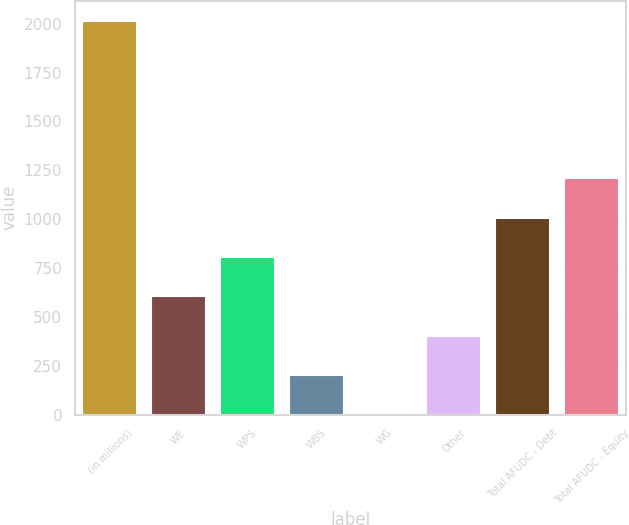Convert chart. <chart><loc_0><loc_0><loc_500><loc_500><bar_chart><fcel>(in millions)<fcel>WE<fcel>WPS<fcel>WBS<fcel>WG<fcel>Other<fcel>Total AFUDC - Debt<fcel>Total AFUDC - Equity<nl><fcel>2016<fcel>604.94<fcel>806.52<fcel>201.78<fcel>0.2<fcel>403.36<fcel>1008.1<fcel>1209.68<nl></chart> 